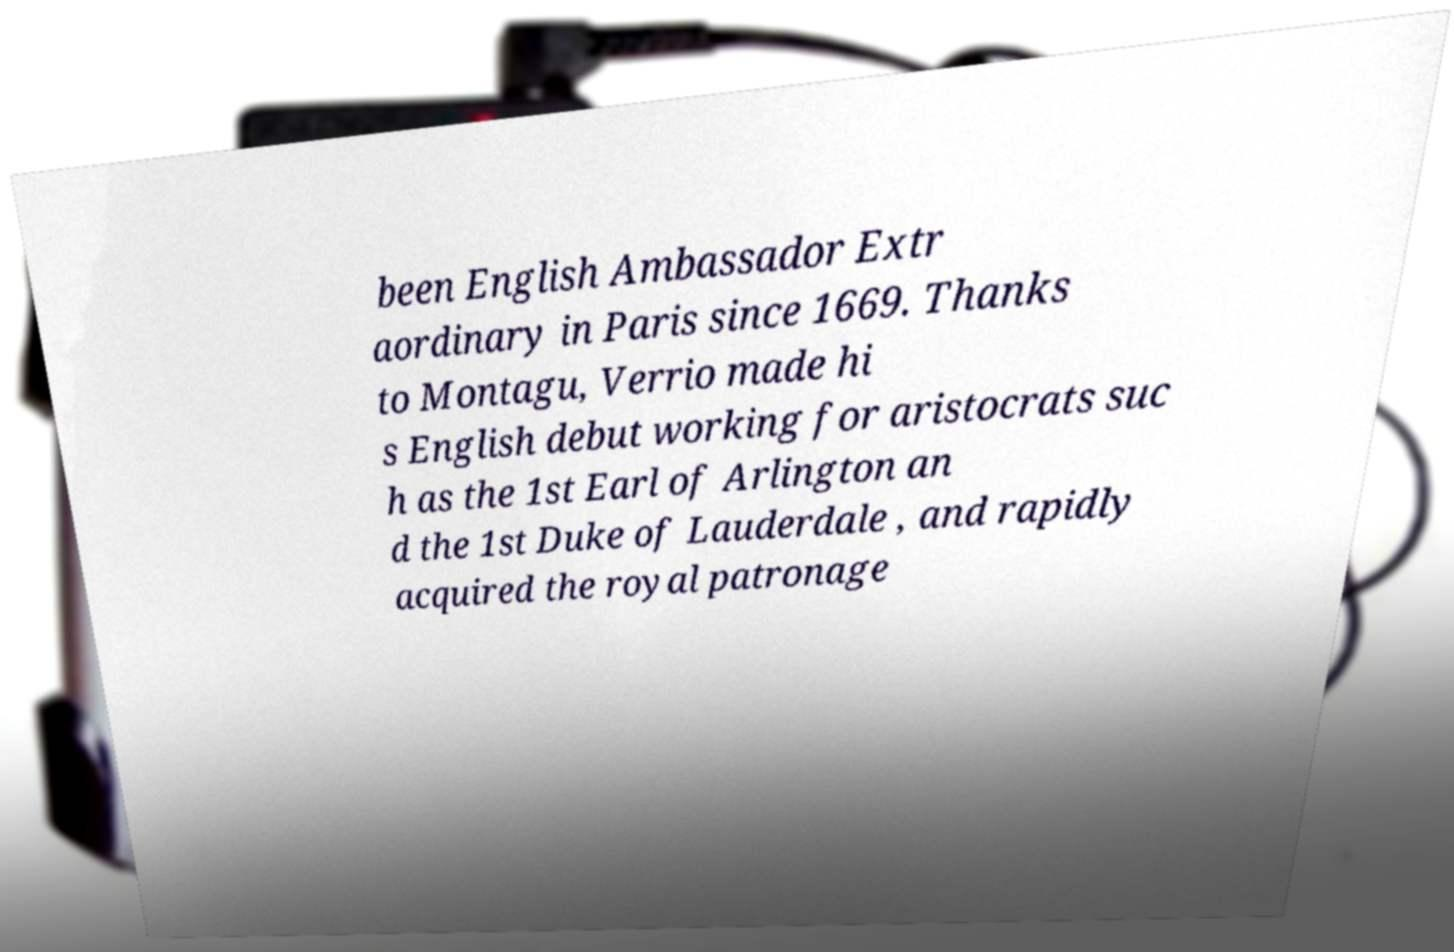Can you read and provide the text displayed in the image?This photo seems to have some interesting text. Can you extract and type it out for me? been English Ambassador Extr aordinary in Paris since 1669. Thanks to Montagu, Verrio made hi s English debut working for aristocrats suc h as the 1st Earl of Arlington an d the 1st Duke of Lauderdale , and rapidly acquired the royal patronage 